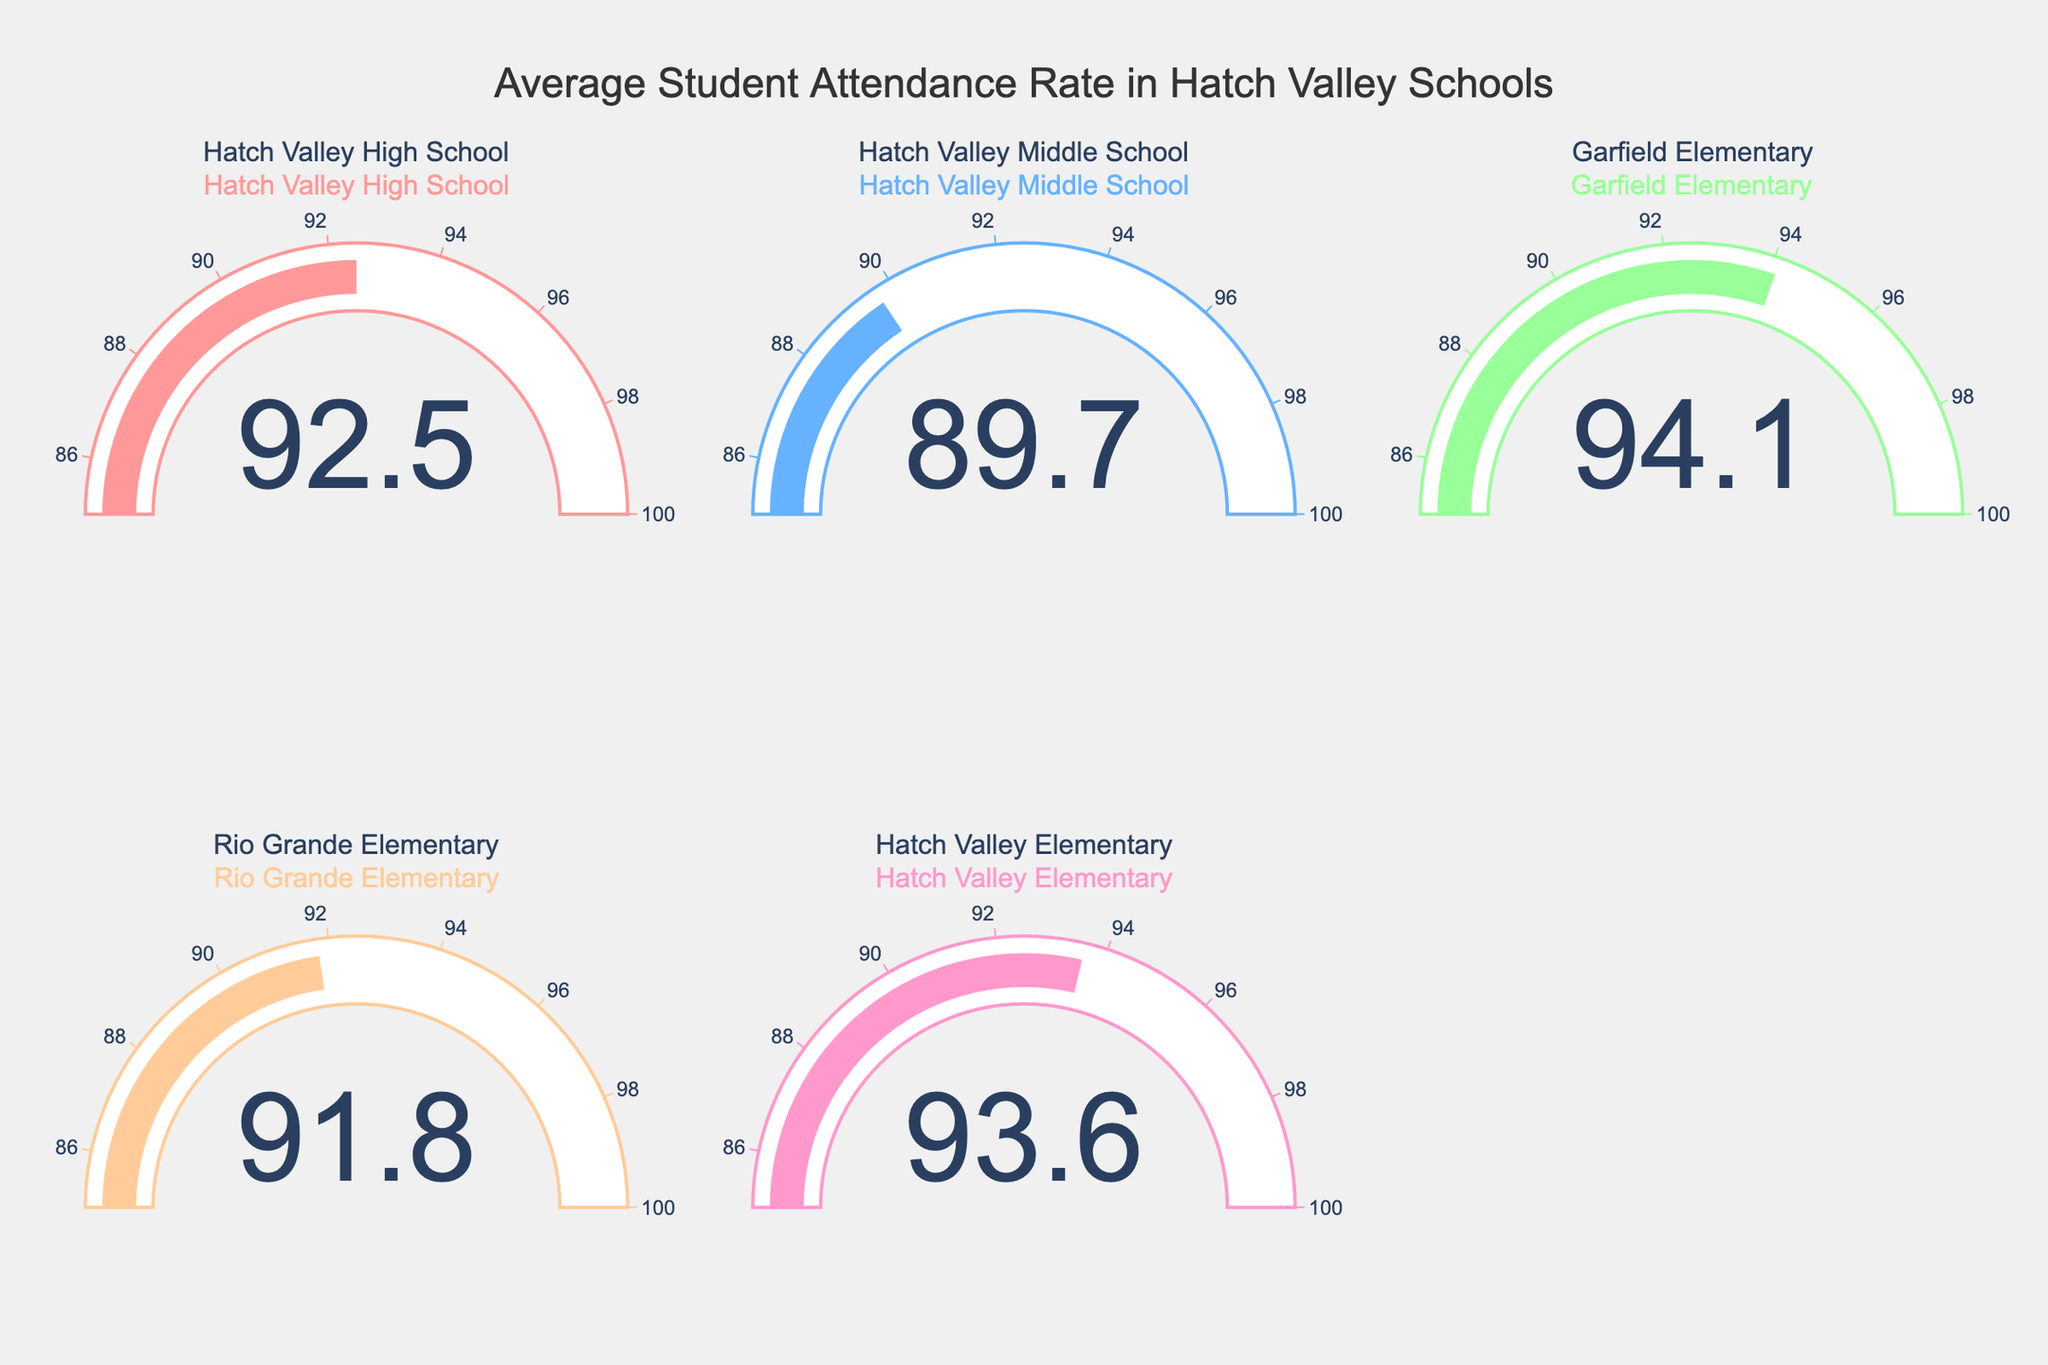What's the average attendance rate across all schools? To find the average attendance rate, add the attendance rates of all schools and divide by the number of schools. (92.5 + 89.7 + 94.1 + 91.8 + 93.6) / 5 = 461.7 / 5 = 92.34
Answer: 92.34 Which school has the highest attendance rate? By comparing the values, Garfield Elementary has the highest attendance rate at 94.1.
Answer: Garfield Elementary Is the attendance rate of Hatch Valley Middle School higher or lower than Hatch Valley Elementary? Hatch Valley Middle School's rate is 89.7, which is lower than Hatch Valley Elementary's rate of 93.6.
Answer: Lower What is the approximate range of the attendance rates shown? The minimum rate is 89.7 (Hatch Valley Middle School) and the maximum rate is 94.1 (Garfield Elementary), so the range is approximately 94.1 - 89.7 = 4.4.
Answer: 4.4 How many schools have an attendance rate above 90%? Hatch Valley High School (92.5), Garfield Elementary (94.1), Rio Grande Elementary (91.8), and Hatch Valley Elementary (93.6) are above 90%. Therefore, 4 schools have rates above 90%.
Answer: 4 Which school has the lowest attendance rate and what is it? Hatch Valley Middle School has the lowest attendance rate at 89.7.
Answer: Hatch Valley Middle School, 89.7 What's the difference in attendance rates between Rio Grande Elementary and Hatch Valley High School? Rio Grande Elementary's rate is 91.8, and Hatch Valley High School's rate is 92.5. The difference is 92.5 - 91.8 = 0.7.
Answer: 0.7 Are there more schools with attendance rates between 85% and 95% or more than 95%? All the schools have attendance rates between 85% and 95%. No school has a rate above 95%. Thus, more schools (all 5) fall within the 85% to 95% range.
Answer: Between 85% and 95% What's the second highest attendance rate and which school has it? The attendance rates in descending order are 94.1 (Garfield Elementary), 93.6 (Hatch Valley Elementary), 92.5 (Hatch Valley High School), 91.8 (Rio Grande Elementary), and 89.7 (Hatch Valley Middle School). The second highest rate is 93.6 at Hatch Valley Elementary.
Answer: 93.6, Hatch Valley Elementary 